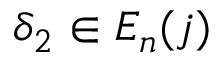Convert formula to latex. <formula><loc_0><loc_0><loc_500><loc_500>\delta _ { 2 } \in E _ { n } ( j )</formula> 